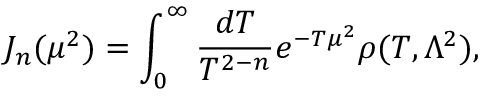<formula> <loc_0><loc_0><loc_500><loc_500>J _ { n } ( \mu ^ { 2 } ) = \int _ { 0 } ^ { \infty } \frac { d T } { T ^ { 2 - n } } e ^ { - T \mu ^ { 2 } } \rho ( T , \Lambda ^ { 2 } ) ,</formula> 